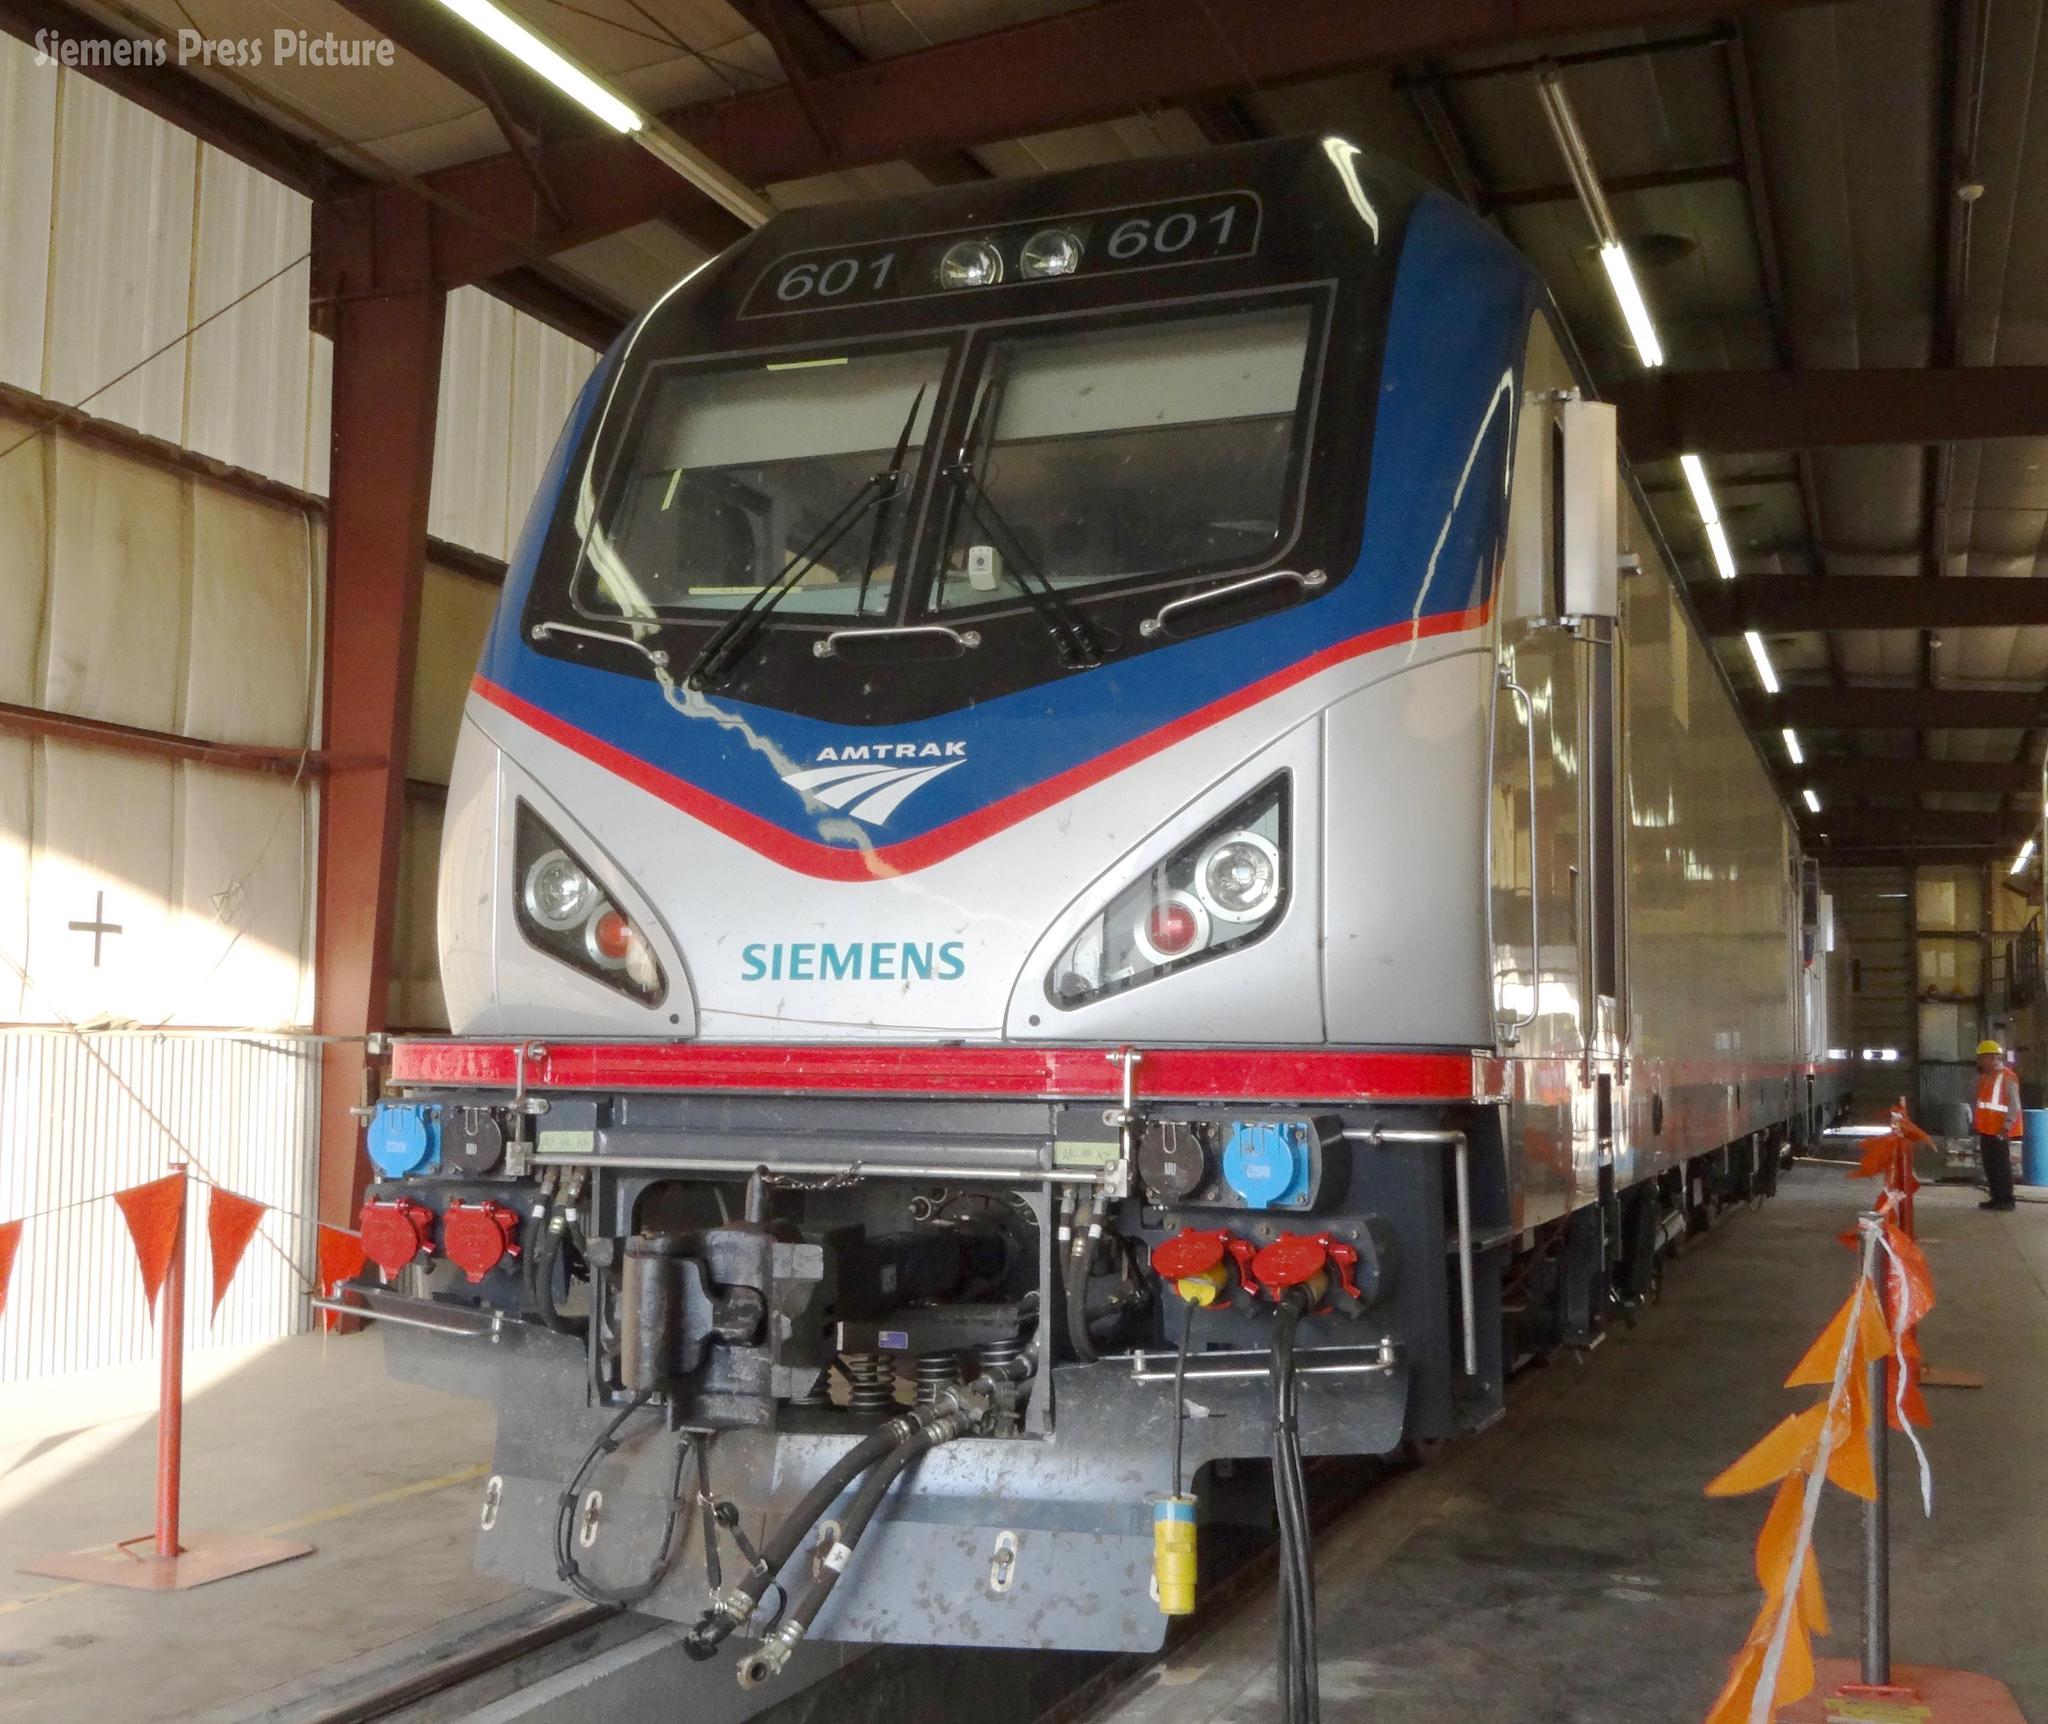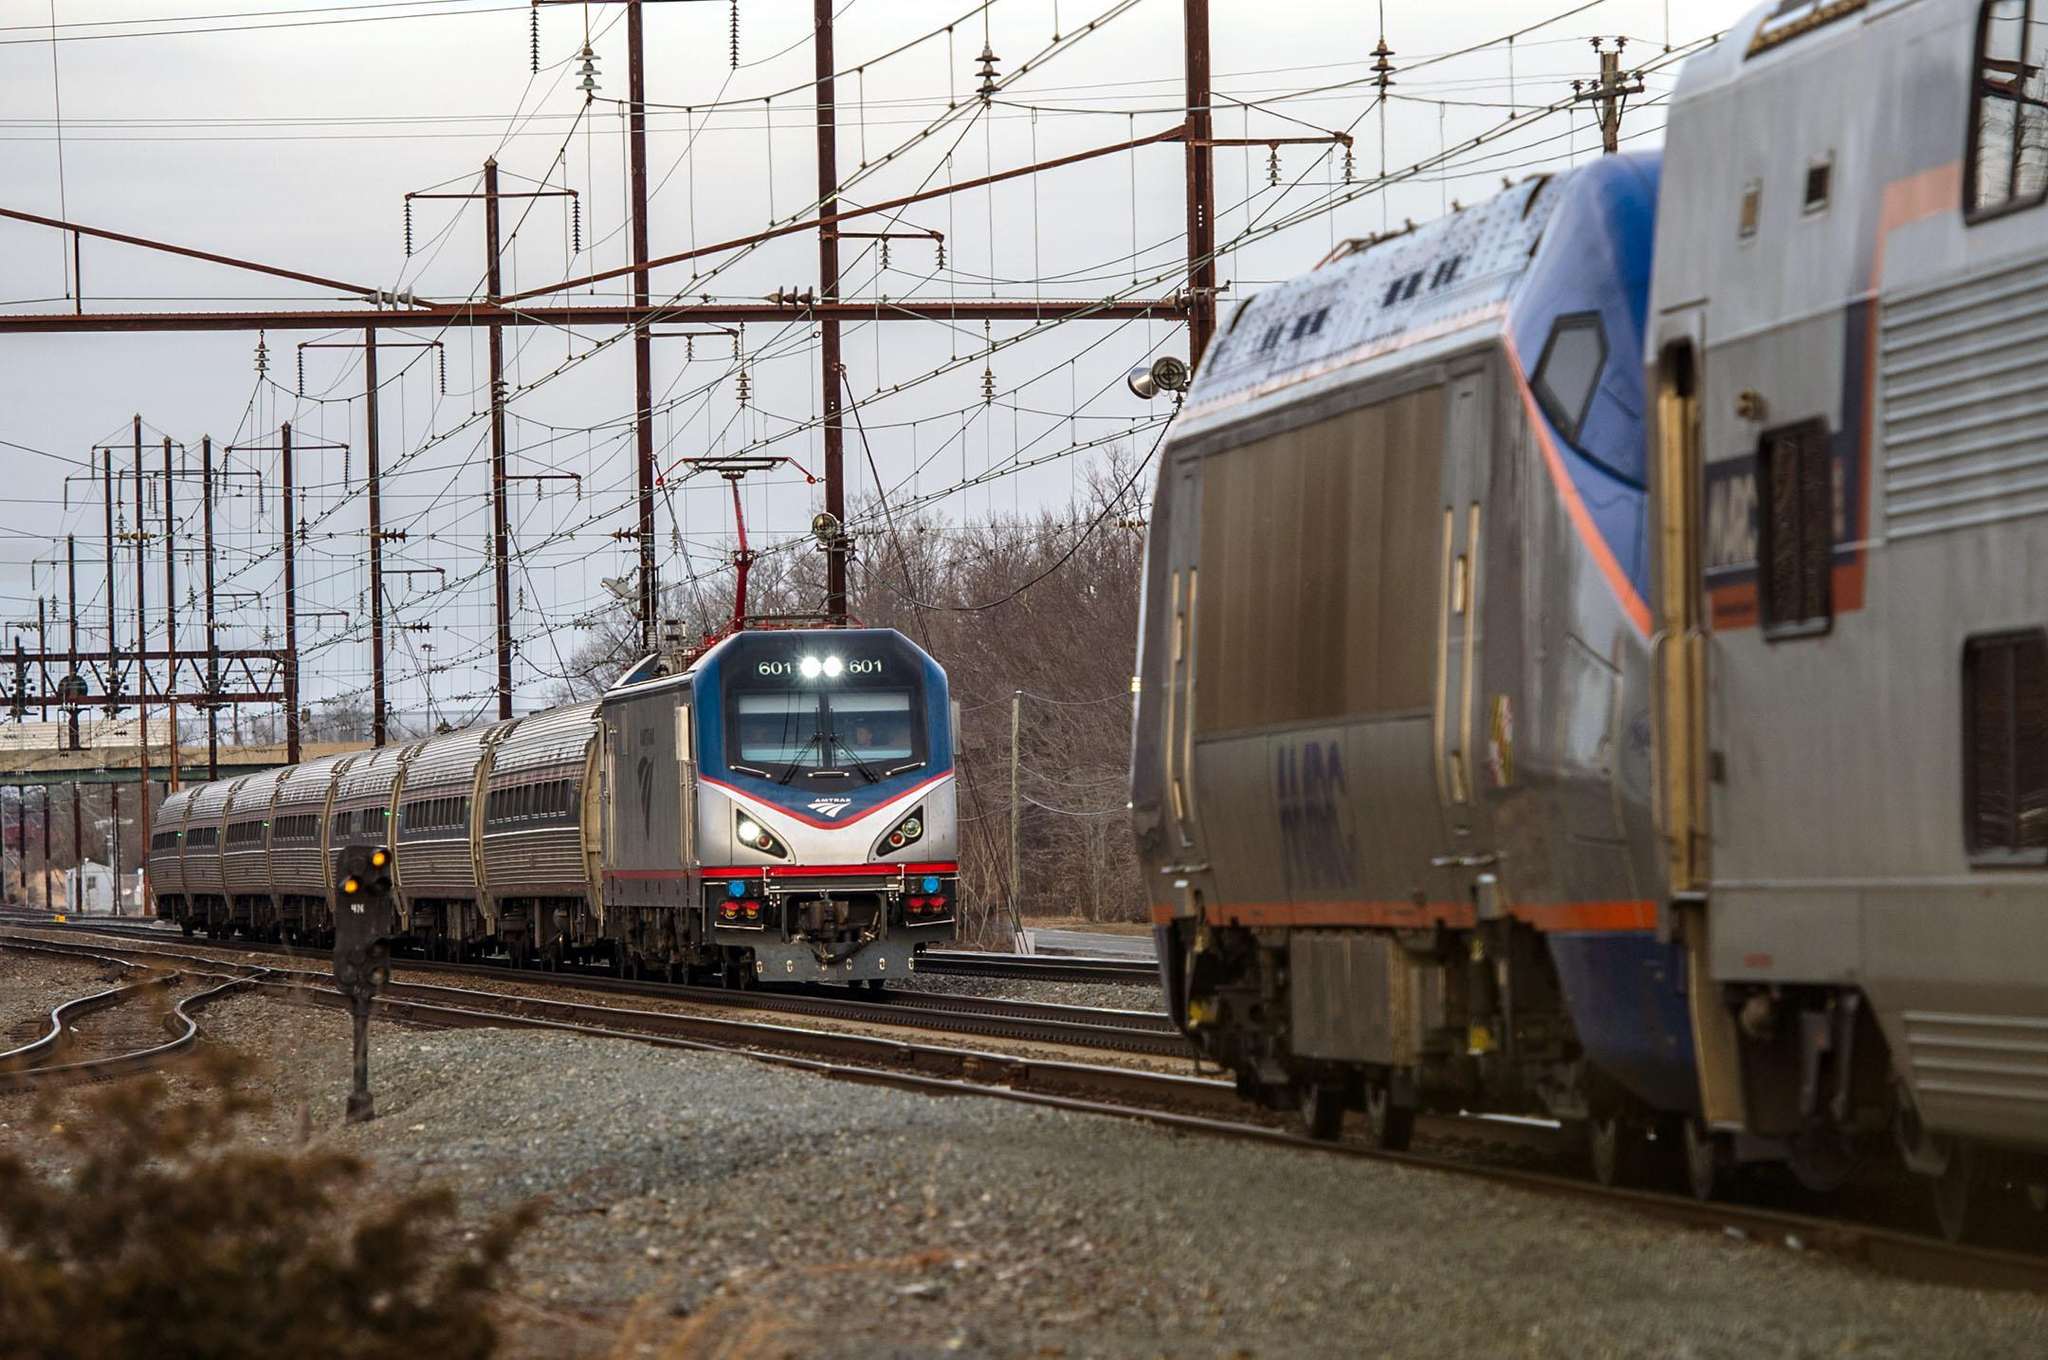The first image is the image on the left, the second image is the image on the right. Given the left and right images, does the statement "There are at least six power poles in the image on the right." hold true? Answer yes or no. Yes. 